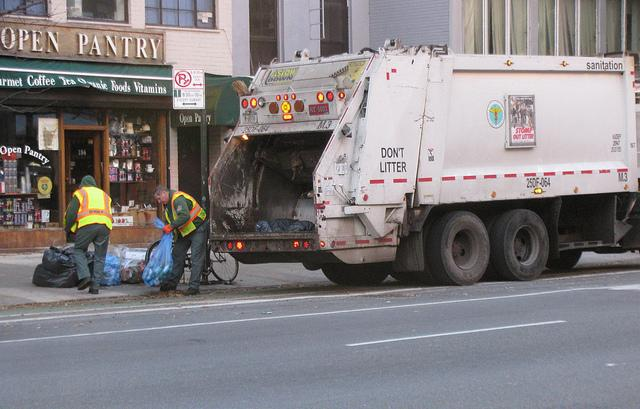Why are the men's vests yellow in color? safety 